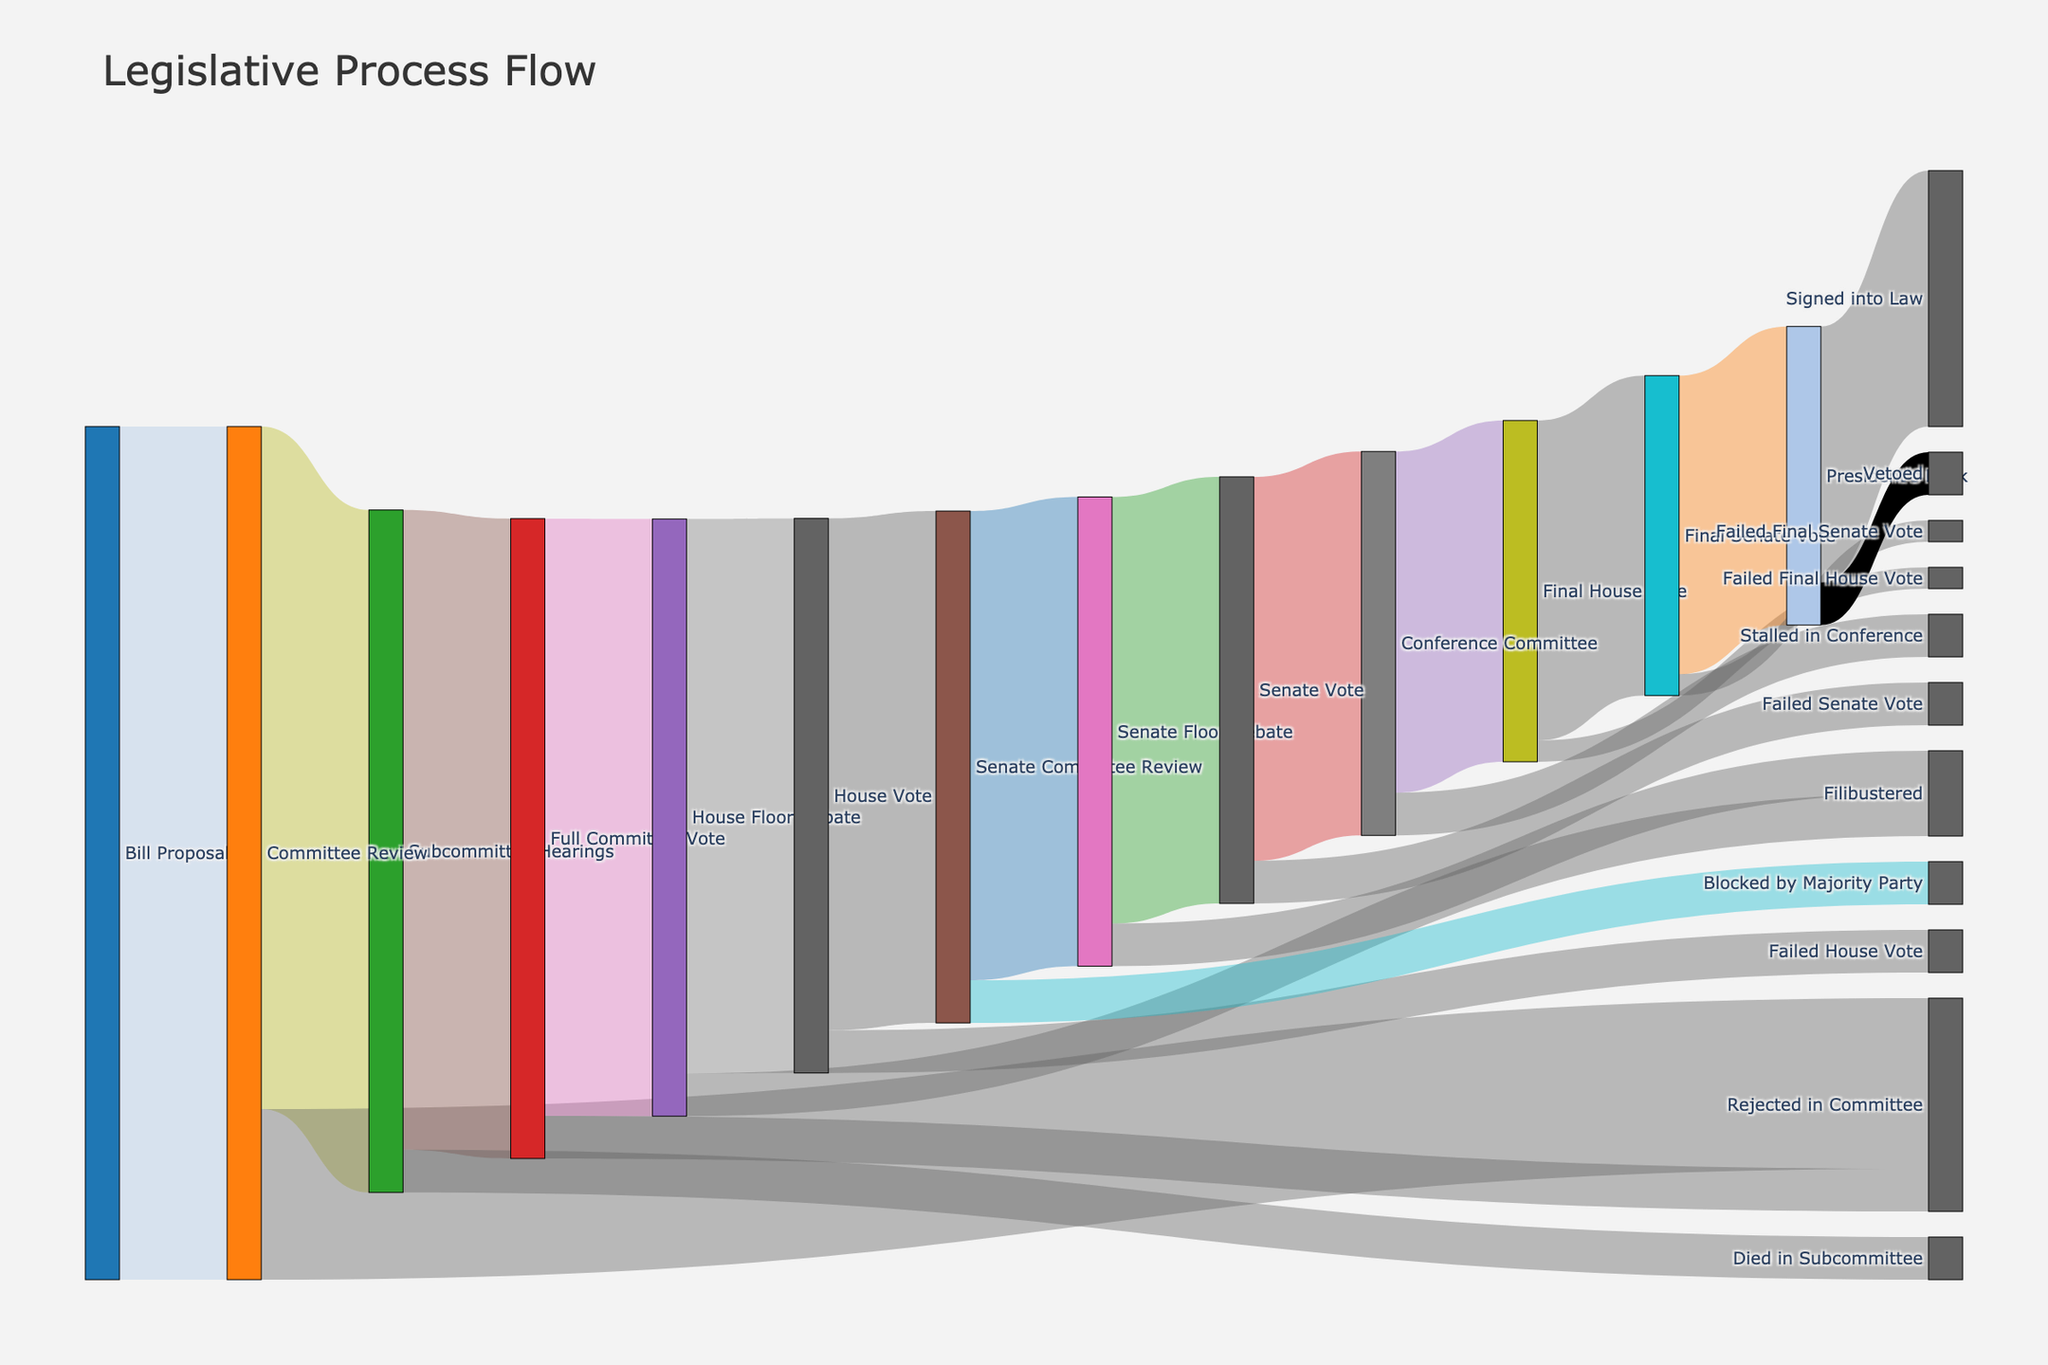What is the title of the Sankey diagram? The Sankey diagram's title is usually prominently displayed at the top of the chart.
Answer: Legislative Process Flow Which stages come directly after 'Bill Proposal'? Look for arrows or flows starting at 'Bill Proposal' and trace them. 'Bill Proposal' leads to 'Committee Review'.
Answer: Committee Review How many bills get rejected during the 'Committee Review' stage? Find the flow labeled 'Rejected in Committee' that stems from 'Committee Review' and check its value.
Answer: 200 What is the total number of bills that reach the 'House Floor Debate' stage? Identify all flows ending in 'House Floor Debate' and sum their values: 700 from 'Full Committee Vote'.
Answer: 700 Which stage has more bills dying, 'Subcommittee Hearings' or 'House Floor Debate' due to filibustering? Compare the values of flows labeled 'Died in Subcommittee' and 'Filibustered' in 'House Floor Debate': 50 each.
Answer: Both have equal value: 50 How many bills make it past the 'Final Senate Vote' stage? Find the flow labeled 'President's Desk' that comes from 'Final Senate Vote' and check its value.
Answer: 350 Which stage immediately follows 'Senate Vote' leading to the highest success rate for bills becoming law? Trace the highest value flow from 'Senate Vote', which is 'Conference Committee' leading to 'Final House Vote'.
Answer: Conference Committee Calculate the overall success rate of bills signed into law starting from 'Bill Proposal'. Divide the final number of bills signed into law (300) by the initial number of bill proposals (1000), then multiply by 100 to get the percentage: (300/1000) * 100.
Answer: 30% Which stage has the highest number of bills getting filibustered? Check the flows labeled 'Filibustered' in 'House Floor Debate' and 'Senate Floor Debate', and compare their values: 50 for each.
Answer: Both have equal value: 50 What is the difference in the number of bills that stall in the 'Conference Committee' stage compared to those rejected at the 'Final Senate Vote'? Subtract the value of bills rejected at the 'Final Senate Vote' (25) from those stalled in 'Conference Committee' (50): 50 - 25.
Answer: 25 